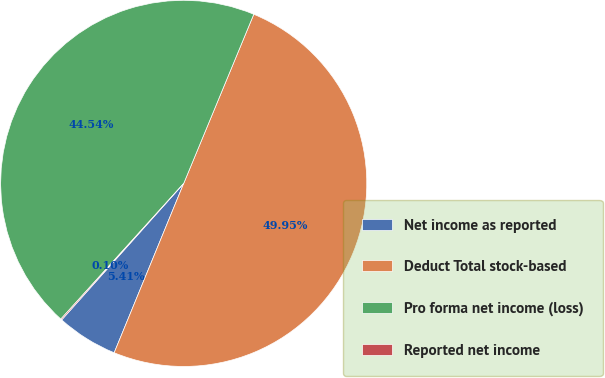Convert chart. <chart><loc_0><loc_0><loc_500><loc_500><pie_chart><fcel>Net income as reported<fcel>Deduct Total stock-based<fcel>Pro forma net income (loss)<fcel>Reported net income<nl><fcel>5.41%<fcel>49.95%<fcel>44.54%<fcel>0.1%<nl></chart> 